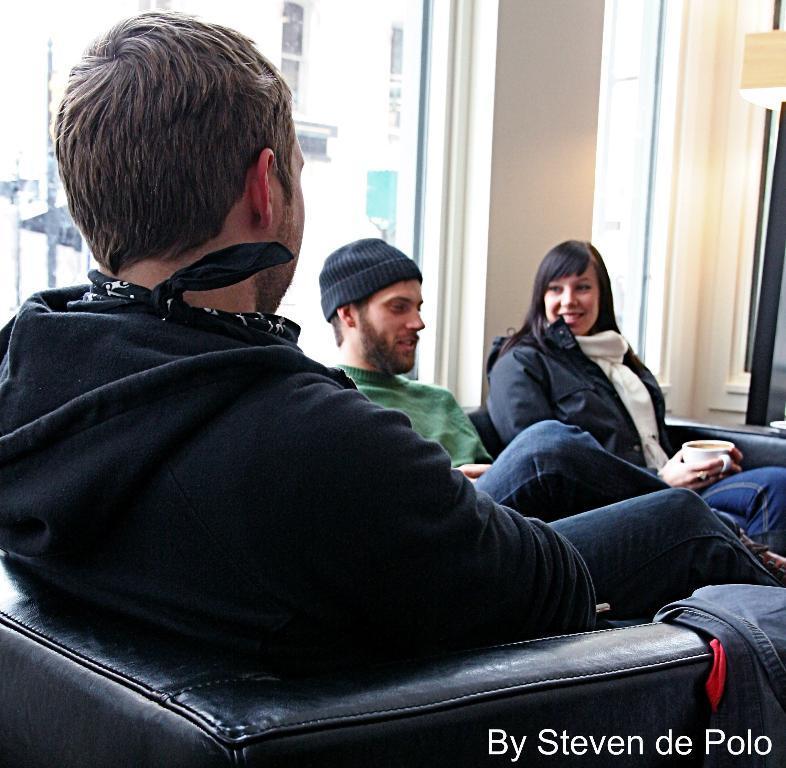How would you summarize this image in a sentence or two? In the center of the image there is a person sitting on the chair. In the background we can see person sitting, building, light, wall and window. 